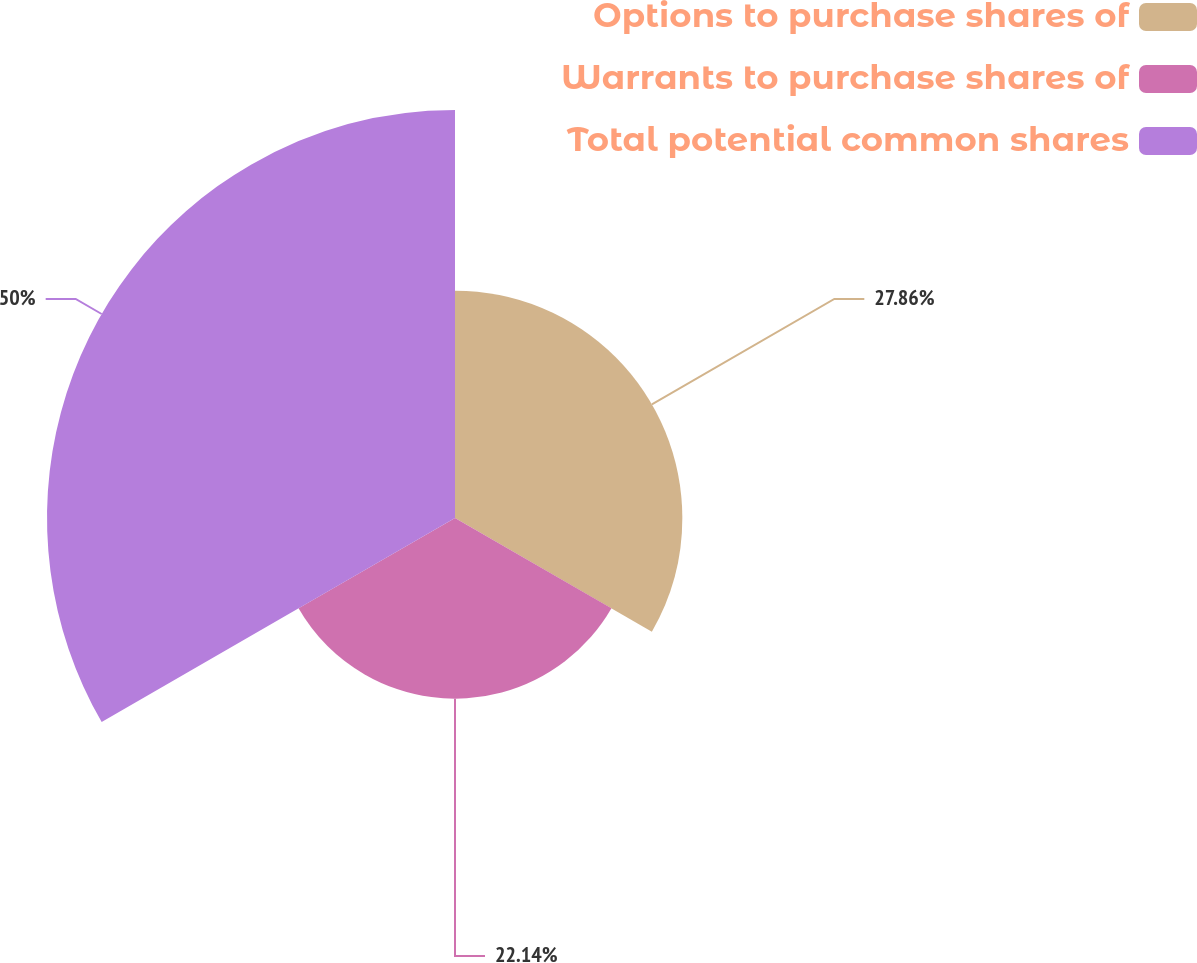Convert chart to OTSL. <chart><loc_0><loc_0><loc_500><loc_500><pie_chart><fcel>Options to purchase shares of<fcel>Warrants to purchase shares of<fcel>Total potential common shares<nl><fcel>27.86%<fcel>22.14%<fcel>50.0%<nl></chart> 